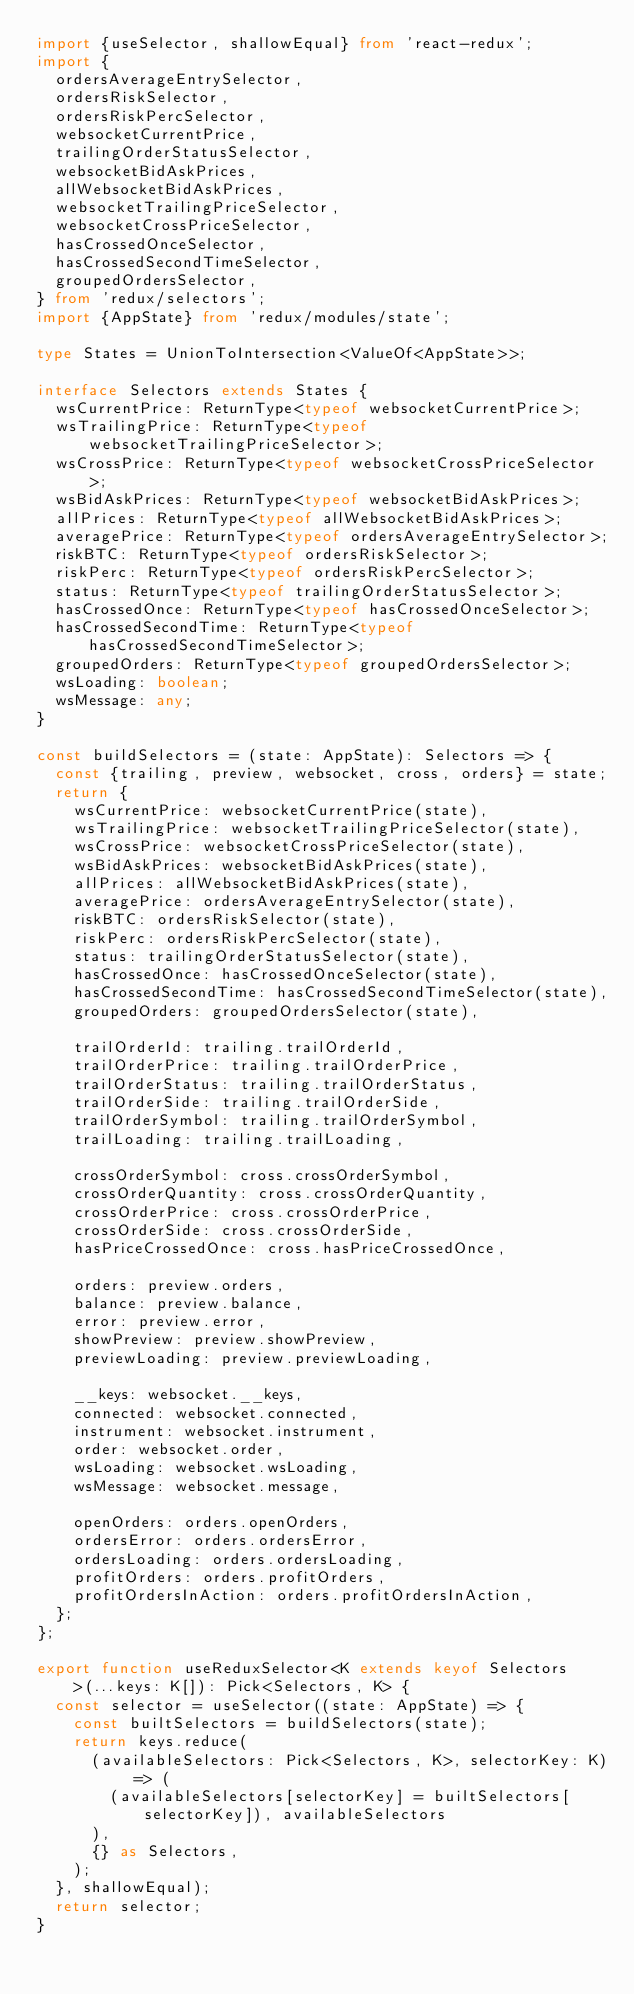<code> <loc_0><loc_0><loc_500><loc_500><_TypeScript_>import {useSelector, shallowEqual} from 'react-redux';
import {
  ordersAverageEntrySelector,
  ordersRiskSelector,
  ordersRiskPercSelector,
  websocketCurrentPrice,
  trailingOrderStatusSelector,
  websocketBidAskPrices,
  allWebsocketBidAskPrices,
  websocketTrailingPriceSelector,
  websocketCrossPriceSelector,
  hasCrossedOnceSelector,
  hasCrossedSecondTimeSelector,
  groupedOrdersSelector,
} from 'redux/selectors';
import {AppState} from 'redux/modules/state';

type States = UnionToIntersection<ValueOf<AppState>>;

interface Selectors extends States {
  wsCurrentPrice: ReturnType<typeof websocketCurrentPrice>;
  wsTrailingPrice: ReturnType<typeof websocketTrailingPriceSelector>;
  wsCrossPrice: ReturnType<typeof websocketCrossPriceSelector>;
  wsBidAskPrices: ReturnType<typeof websocketBidAskPrices>;
  allPrices: ReturnType<typeof allWebsocketBidAskPrices>;
  averagePrice: ReturnType<typeof ordersAverageEntrySelector>;
  riskBTC: ReturnType<typeof ordersRiskSelector>;
  riskPerc: ReturnType<typeof ordersRiskPercSelector>;
  status: ReturnType<typeof trailingOrderStatusSelector>;
  hasCrossedOnce: ReturnType<typeof hasCrossedOnceSelector>;
  hasCrossedSecondTime: ReturnType<typeof hasCrossedSecondTimeSelector>;
  groupedOrders: ReturnType<typeof groupedOrdersSelector>;
  wsLoading: boolean;
  wsMessage: any;
}

const buildSelectors = (state: AppState): Selectors => {
  const {trailing, preview, websocket, cross, orders} = state;
  return {
    wsCurrentPrice: websocketCurrentPrice(state),
    wsTrailingPrice: websocketTrailingPriceSelector(state),
    wsCrossPrice: websocketCrossPriceSelector(state),
    wsBidAskPrices: websocketBidAskPrices(state),
    allPrices: allWebsocketBidAskPrices(state),
    averagePrice: ordersAverageEntrySelector(state),
    riskBTC: ordersRiskSelector(state),
    riskPerc: ordersRiskPercSelector(state),
    status: trailingOrderStatusSelector(state),
    hasCrossedOnce: hasCrossedOnceSelector(state),
    hasCrossedSecondTime: hasCrossedSecondTimeSelector(state),
    groupedOrders: groupedOrdersSelector(state),

    trailOrderId: trailing.trailOrderId,
    trailOrderPrice: trailing.trailOrderPrice,
    trailOrderStatus: trailing.trailOrderStatus,
    trailOrderSide: trailing.trailOrderSide,
    trailOrderSymbol: trailing.trailOrderSymbol,
    trailLoading: trailing.trailLoading,

    crossOrderSymbol: cross.crossOrderSymbol,
    crossOrderQuantity: cross.crossOrderQuantity,
    crossOrderPrice: cross.crossOrderPrice,
    crossOrderSide: cross.crossOrderSide,
    hasPriceCrossedOnce: cross.hasPriceCrossedOnce,

    orders: preview.orders,
    balance: preview.balance,
    error: preview.error,
    showPreview: preview.showPreview,
    previewLoading: preview.previewLoading,

    __keys: websocket.__keys,
    connected: websocket.connected,
    instrument: websocket.instrument,
    order: websocket.order,
    wsLoading: websocket.wsLoading,
    wsMessage: websocket.message,

    openOrders: orders.openOrders,
    ordersError: orders.ordersError,
    ordersLoading: orders.ordersLoading,
    profitOrders: orders.profitOrders,
    profitOrdersInAction: orders.profitOrdersInAction,
  };
};

export function useReduxSelector<K extends keyof Selectors>(...keys: K[]): Pick<Selectors, K> {
  const selector = useSelector((state: AppState) => {
    const builtSelectors = buildSelectors(state);
    return keys.reduce(
      (availableSelectors: Pick<Selectors, K>, selectorKey: K) => (
        (availableSelectors[selectorKey] = builtSelectors[selectorKey]), availableSelectors
      ),
      {} as Selectors,
    );
  }, shallowEqual);
  return selector;
}
</code> 